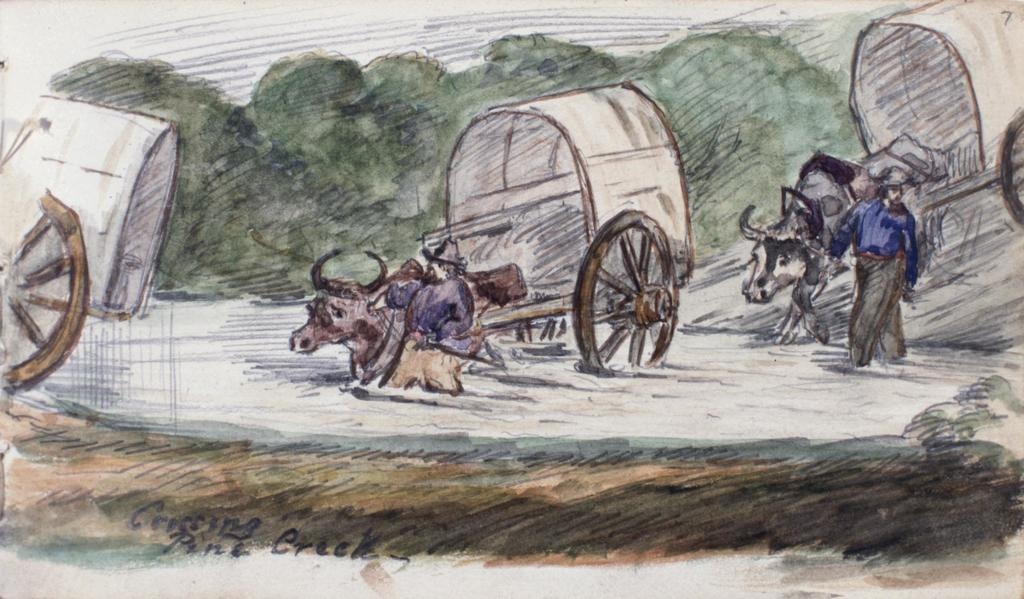What is the main subject of the painting in the image? The painting depicts three cats. How many animals are depicted in the painting? The painting depicts two animals. What is the person in the painting wearing? The person in the painting is wearing a blue shirt. What can be seen in the background of the painting? There is a group of trees in the background of the painting. What type of joke is being told by the person in the painting? There is no joke being told in the painting; it depicts three cats, two animals, a person wearing a blue shirt, and a group of trees in the background. 